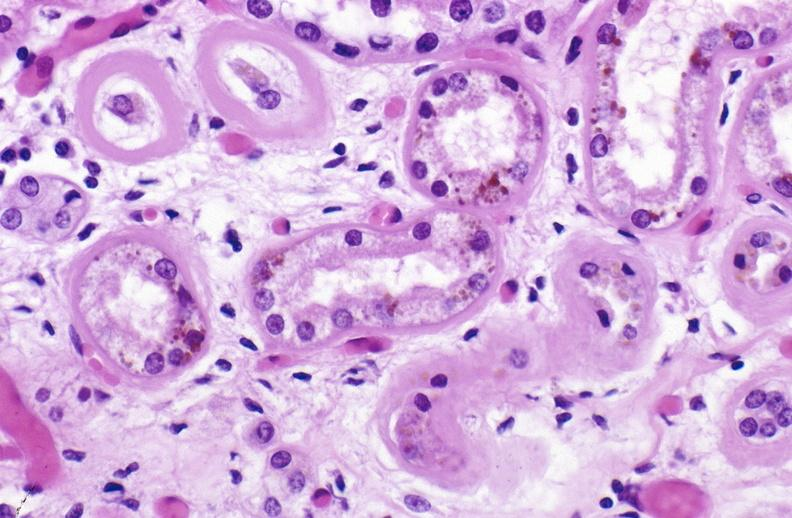what does this image show?
Answer the question using a single word or phrase. Atn and bile pigment 